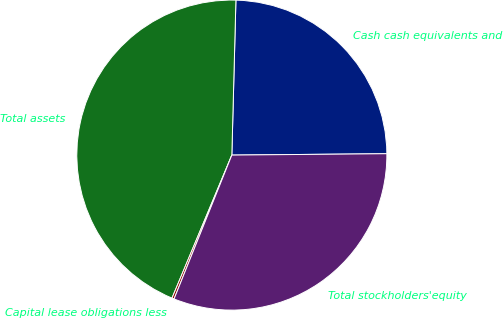Convert chart. <chart><loc_0><loc_0><loc_500><loc_500><pie_chart><fcel>Cash cash equivalents and<fcel>Total assets<fcel>Capital lease obligations less<fcel>Total stockholders'equity<nl><fcel>24.44%<fcel>44.11%<fcel>0.23%<fcel>31.22%<nl></chart> 